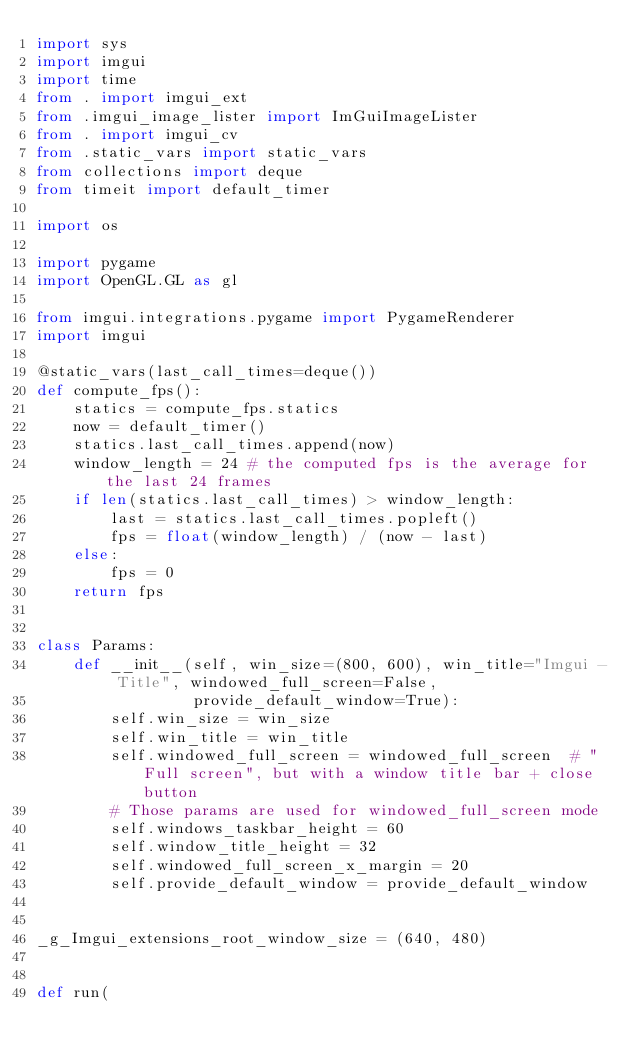Convert code to text. <code><loc_0><loc_0><loc_500><loc_500><_Python_>import sys
import imgui
import time
from . import imgui_ext
from .imgui_image_lister import ImGuiImageLister
from . import imgui_cv
from .static_vars import static_vars
from collections import deque
from timeit import default_timer

import os

import pygame
import OpenGL.GL as gl

from imgui.integrations.pygame import PygameRenderer
import imgui

@static_vars(last_call_times=deque())
def compute_fps():
    statics = compute_fps.statics
    now = default_timer()
    statics.last_call_times.append(now)
    window_length = 24 # the computed fps is the average for the last 24 frames
    if len(statics.last_call_times) > window_length:
        last = statics.last_call_times.popleft()
        fps = float(window_length) / (now - last)
    else:
        fps = 0
    return fps


class Params:
    def __init__(self, win_size=(800, 600), win_title="Imgui - Title", windowed_full_screen=False,
                 provide_default_window=True):
        self.win_size = win_size
        self.win_title = win_title
        self.windowed_full_screen = windowed_full_screen  # "Full screen", but with a window title bar + close button
        # Those params are used for windowed_full_screen mode
        self.windows_taskbar_height = 60
        self.window_title_height = 32
        self.windowed_full_screen_x_margin = 20
        self.provide_default_window = provide_default_window


_g_Imgui_extensions_root_window_size = (640, 480)


def run(</code> 